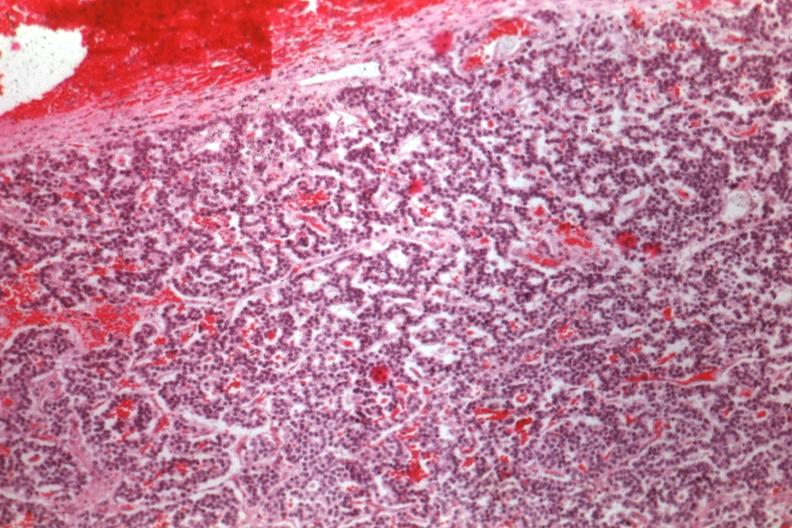what is present?
Answer the question using a single word or phrase. Pituitary 